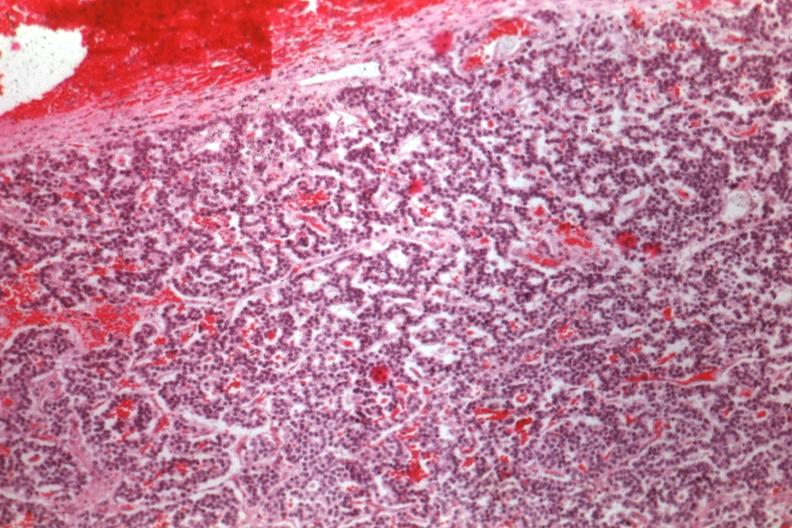what is present?
Answer the question using a single word or phrase. Pituitary 